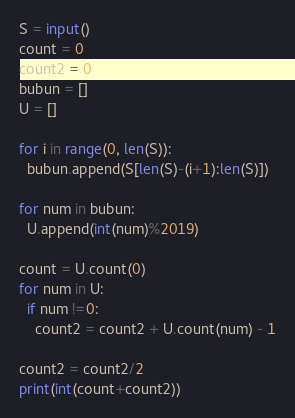<code> <loc_0><loc_0><loc_500><loc_500><_Python_>S = input()
count = 0
count2 = 0
bubun = []
U = []

for i in range(0, len(S)):
  bubun.append(S[len(S)-(i+1):len(S)])

for num in bubun:
  U.append(int(num)%2019)

count = U.count(0)
for num in U:
  if num !=0:
    count2 = count2 + U.count(num) - 1

count2 = count2/2
print(int(count+count2))</code> 